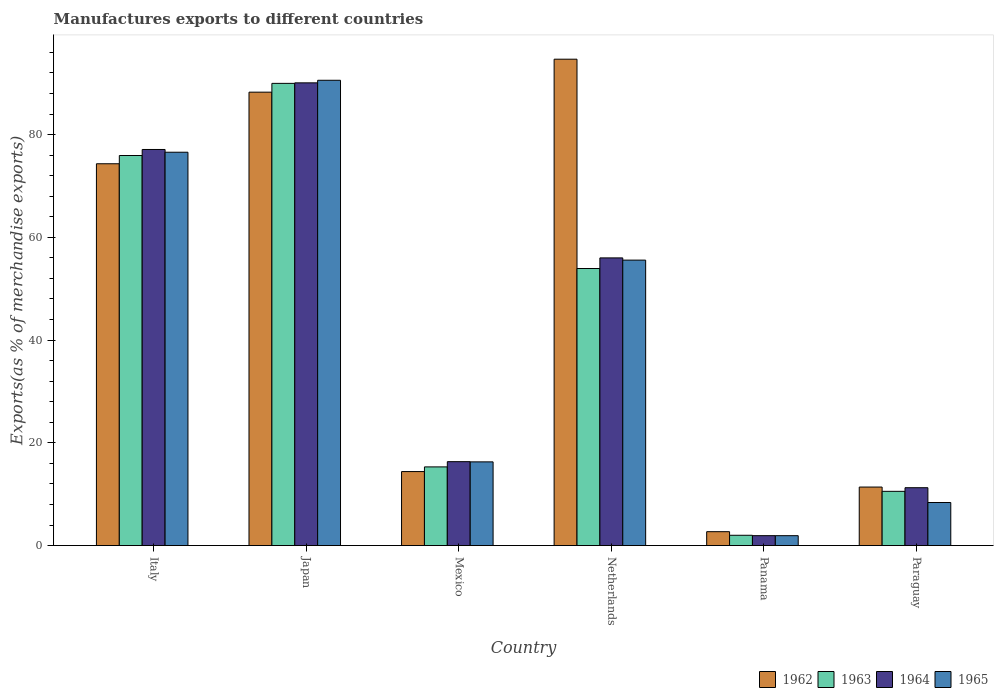How many different coloured bars are there?
Keep it short and to the point. 4. How many groups of bars are there?
Ensure brevity in your answer.  6. Are the number of bars per tick equal to the number of legend labels?
Keep it short and to the point. Yes. Are the number of bars on each tick of the X-axis equal?
Offer a very short reply. Yes. How many bars are there on the 2nd tick from the left?
Your response must be concise. 4. What is the label of the 2nd group of bars from the left?
Your answer should be compact. Japan. What is the percentage of exports to different countries in 1963 in Panama?
Offer a very short reply. 2. Across all countries, what is the maximum percentage of exports to different countries in 1964?
Offer a terse response. 90.07. Across all countries, what is the minimum percentage of exports to different countries in 1965?
Provide a succinct answer. 1.92. In which country was the percentage of exports to different countries in 1964 minimum?
Ensure brevity in your answer.  Panama. What is the total percentage of exports to different countries in 1963 in the graph?
Offer a very short reply. 247.71. What is the difference between the percentage of exports to different countries in 1965 in Netherlands and that in Panama?
Offer a terse response. 53.64. What is the difference between the percentage of exports to different countries in 1963 in Japan and the percentage of exports to different countries in 1964 in Panama?
Give a very brief answer. 88.04. What is the average percentage of exports to different countries in 1965 per country?
Offer a terse response. 41.55. What is the difference between the percentage of exports to different countries of/in 1963 and percentage of exports to different countries of/in 1964 in Italy?
Provide a short and direct response. -1.17. What is the ratio of the percentage of exports to different countries in 1962 in Italy to that in Mexico?
Keep it short and to the point. 5.16. Is the difference between the percentage of exports to different countries in 1963 in Mexico and Paraguay greater than the difference between the percentage of exports to different countries in 1964 in Mexico and Paraguay?
Ensure brevity in your answer.  No. What is the difference between the highest and the second highest percentage of exports to different countries in 1963?
Make the answer very short. 14.04. What is the difference between the highest and the lowest percentage of exports to different countries in 1962?
Keep it short and to the point. 91.97. In how many countries, is the percentage of exports to different countries in 1965 greater than the average percentage of exports to different countries in 1965 taken over all countries?
Your answer should be compact. 3. Is the sum of the percentage of exports to different countries in 1964 in Mexico and Paraguay greater than the maximum percentage of exports to different countries in 1963 across all countries?
Provide a short and direct response. No. Is it the case that in every country, the sum of the percentage of exports to different countries in 1964 and percentage of exports to different countries in 1963 is greater than the sum of percentage of exports to different countries in 1965 and percentage of exports to different countries in 1962?
Give a very brief answer. No. What does the 3rd bar from the left in Panama represents?
Make the answer very short. 1964. What does the 4th bar from the right in Mexico represents?
Your response must be concise. 1962. Is it the case that in every country, the sum of the percentage of exports to different countries in 1964 and percentage of exports to different countries in 1963 is greater than the percentage of exports to different countries in 1962?
Keep it short and to the point. Yes. Does the graph contain any zero values?
Your response must be concise. No. Where does the legend appear in the graph?
Provide a succinct answer. Bottom right. What is the title of the graph?
Offer a very short reply. Manufactures exports to different countries. What is the label or title of the X-axis?
Ensure brevity in your answer.  Country. What is the label or title of the Y-axis?
Your answer should be compact. Exports(as % of merchandise exports). What is the Exports(as % of merchandise exports) in 1962 in Italy?
Your response must be concise. 74.32. What is the Exports(as % of merchandise exports) of 1963 in Italy?
Provide a short and direct response. 75.93. What is the Exports(as % of merchandise exports) in 1964 in Italy?
Give a very brief answer. 77.1. What is the Exports(as % of merchandise exports) in 1965 in Italy?
Provide a short and direct response. 76.57. What is the Exports(as % of merchandise exports) of 1962 in Japan?
Your answer should be compact. 88.26. What is the Exports(as % of merchandise exports) of 1963 in Japan?
Keep it short and to the point. 89.97. What is the Exports(as % of merchandise exports) of 1964 in Japan?
Provide a short and direct response. 90.07. What is the Exports(as % of merchandise exports) of 1965 in Japan?
Give a very brief answer. 90.57. What is the Exports(as % of merchandise exports) in 1962 in Mexico?
Your answer should be very brief. 14.4. What is the Exports(as % of merchandise exports) of 1963 in Mexico?
Make the answer very short. 15.31. What is the Exports(as % of merchandise exports) in 1964 in Mexico?
Your answer should be very brief. 16.33. What is the Exports(as % of merchandise exports) of 1965 in Mexico?
Ensure brevity in your answer.  16.29. What is the Exports(as % of merchandise exports) in 1962 in Netherlands?
Offer a very short reply. 94.68. What is the Exports(as % of merchandise exports) in 1963 in Netherlands?
Keep it short and to the point. 53.93. What is the Exports(as % of merchandise exports) of 1964 in Netherlands?
Your response must be concise. 56. What is the Exports(as % of merchandise exports) of 1965 in Netherlands?
Your response must be concise. 55.57. What is the Exports(as % of merchandise exports) in 1962 in Panama?
Provide a short and direct response. 2.7. What is the Exports(as % of merchandise exports) of 1963 in Panama?
Your response must be concise. 2. What is the Exports(as % of merchandise exports) in 1964 in Panama?
Make the answer very short. 1.93. What is the Exports(as % of merchandise exports) in 1965 in Panama?
Offer a very short reply. 1.92. What is the Exports(as % of merchandise exports) in 1962 in Paraguay?
Offer a terse response. 11.39. What is the Exports(as % of merchandise exports) in 1963 in Paraguay?
Your response must be concise. 10.55. What is the Exports(as % of merchandise exports) of 1964 in Paraguay?
Offer a terse response. 11.26. What is the Exports(as % of merchandise exports) of 1965 in Paraguay?
Provide a short and direct response. 8.38. Across all countries, what is the maximum Exports(as % of merchandise exports) in 1962?
Make the answer very short. 94.68. Across all countries, what is the maximum Exports(as % of merchandise exports) of 1963?
Offer a very short reply. 89.97. Across all countries, what is the maximum Exports(as % of merchandise exports) of 1964?
Provide a short and direct response. 90.07. Across all countries, what is the maximum Exports(as % of merchandise exports) in 1965?
Your answer should be very brief. 90.57. Across all countries, what is the minimum Exports(as % of merchandise exports) in 1962?
Offer a terse response. 2.7. Across all countries, what is the minimum Exports(as % of merchandise exports) in 1963?
Ensure brevity in your answer.  2. Across all countries, what is the minimum Exports(as % of merchandise exports) in 1964?
Your answer should be compact. 1.93. Across all countries, what is the minimum Exports(as % of merchandise exports) in 1965?
Provide a short and direct response. 1.92. What is the total Exports(as % of merchandise exports) of 1962 in the graph?
Offer a terse response. 285.75. What is the total Exports(as % of merchandise exports) in 1963 in the graph?
Your answer should be compact. 247.71. What is the total Exports(as % of merchandise exports) of 1964 in the graph?
Ensure brevity in your answer.  252.69. What is the total Exports(as % of merchandise exports) in 1965 in the graph?
Offer a very short reply. 249.3. What is the difference between the Exports(as % of merchandise exports) of 1962 in Italy and that in Japan?
Your response must be concise. -13.94. What is the difference between the Exports(as % of merchandise exports) in 1963 in Italy and that in Japan?
Provide a short and direct response. -14.04. What is the difference between the Exports(as % of merchandise exports) in 1964 in Italy and that in Japan?
Your answer should be very brief. -12.97. What is the difference between the Exports(as % of merchandise exports) in 1965 in Italy and that in Japan?
Provide a short and direct response. -14.01. What is the difference between the Exports(as % of merchandise exports) in 1962 in Italy and that in Mexico?
Offer a very short reply. 59.92. What is the difference between the Exports(as % of merchandise exports) in 1963 in Italy and that in Mexico?
Offer a very short reply. 60.61. What is the difference between the Exports(as % of merchandise exports) in 1964 in Italy and that in Mexico?
Keep it short and to the point. 60.77. What is the difference between the Exports(as % of merchandise exports) of 1965 in Italy and that in Mexico?
Your response must be concise. 60.28. What is the difference between the Exports(as % of merchandise exports) of 1962 in Italy and that in Netherlands?
Make the answer very short. -20.36. What is the difference between the Exports(as % of merchandise exports) of 1963 in Italy and that in Netherlands?
Keep it short and to the point. 22. What is the difference between the Exports(as % of merchandise exports) in 1964 in Italy and that in Netherlands?
Make the answer very short. 21.11. What is the difference between the Exports(as % of merchandise exports) of 1965 in Italy and that in Netherlands?
Your response must be concise. 21. What is the difference between the Exports(as % of merchandise exports) of 1962 in Italy and that in Panama?
Make the answer very short. 71.62. What is the difference between the Exports(as % of merchandise exports) of 1963 in Italy and that in Panama?
Make the answer very short. 73.92. What is the difference between the Exports(as % of merchandise exports) in 1964 in Italy and that in Panama?
Your response must be concise. 75.18. What is the difference between the Exports(as % of merchandise exports) of 1965 in Italy and that in Panama?
Ensure brevity in your answer.  74.64. What is the difference between the Exports(as % of merchandise exports) of 1962 in Italy and that in Paraguay?
Provide a short and direct response. 62.93. What is the difference between the Exports(as % of merchandise exports) of 1963 in Italy and that in Paraguay?
Give a very brief answer. 65.37. What is the difference between the Exports(as % of merchandise exports) in 1964 in Italy and that in Paraguay?
Your answer should be very brief. 65.84. What is the difference between the Exports(as % of merchandise exports) in 1965 in Italy and that in Paraguay?
Your answer should be compact. 68.19. What is the difference between the Exports(as % of merchandise exports) of 1962 in Japan and that in Mexico?
Ensure brevity in your answer.  73.86. What is the difference between the Exports(as % of merchandise exports) in 1963 in Japan and that in Mexico?
Provide a short and direct response. 74.66. What is the difference between the Exports(as % of merchandise exports) in 1964 in Japan and that in Mexico?
Ensure brevity in your answer.  73.74. What is the difference between the Exports(as % of merchandise exports) in 1965 in Japan and that in Mexico?
Keep it short and to the point. 74.28. What is the difference between the Exports(as % of merchandise exports) of 1962 in Japan and that in Netherlands?
Your answer should be very brief. -6.42. What is the difference between the Exports(as % of merchandise exports) of 1963 in Japan and that in Netherlands?
Provide a short and direct response. 36.04. What is the difference between the Exports(as % of merchandise exports) in 1964 in Japan and that in Netherlands?
Provide a succinct answer. 34.07. What is the difference between the Exports(as % of merchandise exports) in 1965 in Japan and that in Netherlands?
Keep it short and to the point. 35.01. What is the difference between the Exports(as % of merchandise exports) in 1962 in Japan and that in Panama?
Give a very brief answer. 85.56. What is the difference between the Exports(as % of merchandise exports) in 1963 in Japan and that in Panama?
Your response must be concise. 87.97. What is the difference between the Exports(as % of merchandise exports) in 1964 in Japan and that in Panama?
Ensure brevity in your answer.  88.15. What is the difference between the Exports(as % of merchandise exports) of 1965 in Japan and that in Panama?
Your answer should be compact. 88.65. What is the difference between the Exports(as % of merchandise exports) in 1962 in Japan and that in Paraguay?
Your answer should be very brief. 76.87. What is the difference between the Exports(as % of merchandise exports) in 1963 in Japan and that in Paraguay?
Make the answer very short. 79.42. What is the difference between the Exports(as % of merchandise exports) of 1964 in Japan and that in Paraguay?
Ensure brevity in your answer.  78.81. What is the difference between the Exports(as % of merchandise exports) of 1965 in Japan and that in Paraguay?
Your answer should be very brief. 82.19. What is the difference between the Exports(as % of merchandise exports) of 1962 in Mexico and that in Netherlands?
Your answer should be very brief. -80.27. What is the difference between the Exports(as % of merchandise exports) of 1963 in Mexico and that in Netherlands?
Provide a short and direct response. -38.62. What is the difference between the Exports(as % of merchandise exports) of 1964 in Mexico and that in Netherlands?
Make the answer very short. -39.67. What is the difference between the Exports(as % of merchandise exports) in 1965 in Mexico and that in Netherlands?
Offer a very short reply. -39.28. What is the difference between the Exports(as % of merchandise exports) in 1962 in Mexico and that in Panama?
Give a very brief answer. 11.7. What is the difference between the Exports(as % of merchandise exports) of 1963 in Mexico and that in Panama?
Provide a short and direct response. 13.31. What is the difference between the Exports(as % of merchandise exports) of 1964 in Mexico and that in Panama?
Make the answer very short. 14.4. What is the difference between the Exports(as % of merchandise exports) of 1965 in Mexico and that in Panama?
Your response must be concise. 14.37. What is the difference between the Exports(as % of merchandise exports) in 1962 in Mexico and that in Paraguay?
Your response must be concise. 3.01. What is the difference between the Exports(as % of merchandise exports) in 1963 in Mexico and that in Paraguay?
Offer a very short reply. 4.76. What is the difference between the Exports(as % of merchandise exports) of 1964 in Mexico and that in Paraguay?
Offer a terse response. 5.07. What is the difference between the Exports(as % of merchandise exports) of 1965 in Mexico and that in Paraguay?
Provide a short and direct response. 7.91. What is the difference between the Exports(as % of merchandise exports) in 1962 in Netherlands and that in Panama?
Ensure brevity in your answer.  91.97. What is the difference between the Exports(as % of merchandise exports) of 1963 in Netherlands and that in Panama?
Give a very brief answer. 51.93. What is the difference between the Exports(as % of merchandise exports) of 1964 in Netherlands and that in Panama?
Give a very brief answer. 54.07. What is the difference between the Exports(as % of merchandise exports) in 1965 in Netherlands and that in Panama?
Offer a terse response. 53.64. What is the difference between the Exports(as % of merchandise exports) of 1962 in Netherlands and that in Paraguay?
Keep it short and to the point. 83.29. What is the difference between the Exports(as % of merchandise exports) of 1963 in Netherlands and that in Paraguay?
Your answer should be very brief. 43.38. What is the difference between the Exports(as % of merchandise exports) in 1964 in Netherlands and that in Paraguay?
Make the answer very short. 44.74. What is the difference between the Exports(as % of merchandise exports) of 1965 in Netherlands and that in Paraguay?
Offer a very short reply. 47.19. What is the difference between the Exports(as % of merchandise exports) of 1962 in Panama and that in Paraguay?
Keep it short and to the point. -8.69. What is the difference between the Exports(as % of merchandise exports) in 1963 in Panama and that in Paraguay?
Your answer should be very brief. -8.55. What is the difference between the Exports(as % of merchandise exports) in 1964 in Panama and that in Paraguay?
Ensure brevity in your answer.  -9.33. What is the difference between the Exports(as % of merchandise exports) of 1965 in Panama and that in Paraguay?
Provide a short and direct response. -6.46. What is the difference between the Exports(as % of merchandise exports) in 1962 in Italy and the Exports(as % of merchandise exports) in 1963 in Japan?
Offer a very short reply. -15.65. What is the difference between the Exports(as % of merchandise exports) of 1962 in Italy and the Exports(as % of merchandise exports) of 1964 in Japan?
Your response must be concise. -15.75. What is the difference between the Exports(as % of merchandise exports) of 1962 in Italy and the Exports(as % of merchandise exports) of 1965 in Japan?
Your answer should be compact. -16.25. What is the difference between the Exports(as % of merchandise exports) of 1963 in Italy and the Exports(as % of merchandise exports) of 1964 in Japan?
Keep it short and to the point. -14.14. What is the difference between the Exports(as % of merchandise exports) in 1963 in Italy and the Exports(as % of merchandise exports) in 1965 in Japan?
Offer a terse response. -14.64. What is the difference between the Exports(as % of merchandise exports) in 1964 in Italy and the Exports(as % of merchandise exports) in 1965 in Japan?
Your answer should be very brief. -13.47. What is the difference between the Exports(as % of merchandise exports) in 1962 in Italy and the Exports(as % of merchandise exports) in 1963 in Mexico?
Make the answer very short. 59.01. What is the difference between the Exports(as % of merchandise exports) in 1962 in Italy and the Exports(as % of merchandise exports) in 1964 in Mexico?
Your answer should be very brief. 57.99. What is the difference between the Exports(as % of merchandise exports) in 1962 in Italy and the Exports(as % of merchandise exports) in 1965 in Mexico?
Offer a terse response. 58.03. What is the difference between the Exports(as % of merchandise exports) of 1963 in Italy and the Exports(as % of merchandise exports) of 1964 in Mexico?
Offer a terse response. 59.6. What is the difference between the Exports(as % of merchandise exports) in 1963 in Italy and the Exports(as % of merchandise exports) in 1965 in Mexico?
Your answer should be very brief. 59.64. What is the difference between the Exports(as % of merchandise exports) in 1964 in Italy and the Exports(as % of merchandise exports) in 1965 in Mexico?
Your answer should be compact. 60.81. What is the difference between the Exports(as % of merchandise exports) in 1962 in Italy and the Exports(as % of merchandise exports) in 1963 in Netherlands?
Keep it short and to the point. 20.39. What is the difference between the Exports(as % of merchandise exports) in 1962 in Italy and the Exports(as % of merchandise exports) in 1964 in Netherlands?
Give a very brief answer. 18.32. What is the difference between the Exports(as % of merchandise exports) of 1962 in Italy and the Exports(as % of merchandise exports) of 1965 in Netherlands?
Your answer should be very brief. 18.76. What is the difference between the Exports(as % of merchandise exports) of 1963 in Italy and the Exports(as % of merchandise exports) of 1964 in Netherlands?
Provide a short and direct response. 19.93. What is the difference between the Exports(as % of merchandise exports) in 1963 in Italy and the Exports(as % of merchandise exports) in 1965 in Netherlands?
Ensure brevity in your answer.  20.36. What is the difference between the Exports(as % of merchandise exports) of 1964 in Italy and the Exports(as % of merchandise exports) of 1965 in Netherlands?
Keep it short and to the point. 21.54. What is the difference between the Exports(as % of merchandise exports) of 1962 in Italy and the Exports(as % of merchandise exports) of 1963 in Panama?
Provide a succinct answer. 72.32. What is the difference between the Exports(as % of merchandise exports) in 1962 in Italy and the Exports(as % of merchandise exports) in 1964 in Panama?
Offer a very short reply. 72.39. What is the difference between the Exports(as % of merchandise exports) in 1962 in Italy and the Exports(as % of merchandise exports) in 1965 in Panama?
Your response must be concise. 72.4. What is the difference between the Exports(as % of merchandise exports) in 1963 in Italy and the Exports(as % of merchandise exports) in 1964 in Panama?
Provide a succinct answer. 74. What is the difference between the Exports(as % of merchandise exports) in 1963 in Italy and the Exports(as % of merchandise exports) in 1965 in Panama?
Your response must be concise. 74.01. What is the difference between the Exports(as % of merchandise exports) in 1964 in Italy and the Exports(as % of merchandise exports) in 1965 in Panama?
Provide a succinct answer. 75.18. What is the difference between the Exports(as % of merchandise exports) of 1962 in Italy and the Exports(as % of merchandise exports) of 1963 in Paraguay?
Your answer should be very brief. 63.77. What is the difference between the Exports(as % of merchandise exports) in 1962 in Italy and the Exports(as % of merchandise exports) in 1964 in Paraguay?
Offer a terse response. 63.06. What is the difference between the Exports(as % of merchandise exports) of 1962 in Italy and the Exports(as % of merchandise exports) of 1965 in Paraguay?
Provide a succinct answer. 65.94. What is the difference between the Exports(as % of merchandise exports) of 1963 in Italy and the Exports(as % of merchandise exports) of 1964 in Paraguay?
Keep it short and to the point. 64.67. What is the difference between the Exports(as % of merchandise exports) of 1963 in Italy and the Exports(as % of merchandise exports) of 1965 in Paraguay?
Provide a succinct answer. 67.55. What is the difference between the Exports(as % of merchandise exports) in 1964 in Italy and the Exports(as % of merchandise exports) in 1965 in Paraguay?
Your answer should be compact. 68.72. What is the difference between the Exports(as % of merchandise exports) of 1962 in Japan and the Exports(as % of merchandise exports) of 1963 in Mexico?
Your response must be concise. 72.95. What is the difference between the Exports(as % of merchandise exports) of 1962 in Japan and the Exports(as % of merchandise exports) of 1964 in Mexico?
Offer a very short reply. 71.93. What is the difference between the Exports(as % of merchandise exports) in 1962 in Japan and the Exports(as % of merchandise exports) in 1965 in Mexico?
Offer a terse response. 71.97. What is the difference between the Exports(as % of merchandise exports) in 1963 in Japan and the Exports(as % of merchandise exports) in 1964 in Mexico?
Provide a succinct answer. 73.64. What is the difference between the Exports(as % of merchandise exports) in 1963 in Japan and the Exports(as % of merchandise exports) in 1965 in Mexico?
Your answer should be very brief. 73.68. What is the difference between the Exports(as % of merchandise exports) in 1964 in Japan and the Exports(as % of merchandise exports) in 1965 in Mexico?
Your answer should be compact. 73.78. What is the difference between the Exports(as % of merchandise exports) in 1962 in Japan and the Exports(as % of merchandise exports) in 1963 in Netherlands?
Provide a succinct answer. 34.33. What is the difference between the Exports(as % of merchandise exports) of 1962 in Japan and the Exports(as % of merchandise exports) of 1964 in Netherlands?
Make the answer very short. 32.26. What is the difference between the Exports(as % of merchandise exports) in 1962 in Japan and the Exports(as % of merchandise exports) in 1965 in Netherlands?
Your answer should be compact. 32.69. What is the difference between the Exports(as % of merchandise exports) in 1963 in Japan and the Exports(as % of merchandise exports) in 1964 in Netherlands?
Provide a short and direct response. 33.97. What is the difference between the Exports(as % of merchandise exports) of 1963 in Japan and the Exports(as % of merchandise exports) of 1965 in Netherlands?
Make the answer very short. 34.41. What is the difference between the Exports(as % of merchandise exports) of 1964 in Japan and the Exports(as % of merchandise exports) of 1965 in Netherlands?
Ensure brevity in your answer.  34.51. What is the difference between the Exports(as % of merchandise exports) of 1962 in Japan and the Exports(as % of merchandise exports) of 1963 in Panama?
Make the answer very short. 86.26. What is the difference between the Exports(as % of merchandise exports) of 1962 in Japan and the Exports(as % of merchandise exports) of 1964 in Panama?
Your response must be concise. 86.33. What is the difference between the Exports(as % of merchandise exports) of 1962 in Japan and the Exports(as % of merchandise exports) of 1965 in Panama?
Your answer should be very brief. 86.34. What is the difference between the Exports(as % of merchandise exports) of 1963 in Japan and the Exports(as % of merchandise exports) of 1964 in Panama?
Offer a terse response. 88.05. What is the difference between the Exports(as % of merchandise exports) of 1963 in Japan and the Exports(as % of merchandise exports) of 1965 in Panama?
Your answer should be compact. 88.05. What is the difference between the Exports(as % of merchandise exports) of 1964 in Japan and the Exports(as % of merchandise exports) of 1965 in Panama?
Your answer should be very brief. 88.15. What is the difference between the Exports(as % of merchandise exports) in 1962 in Japan and the Exports(as % of merchandise exports) in 1963 in Paraguay?
Offer a terse response. 77.71. What is the difference between the Exports(as % of merchandise exports) in 1962 in Japan and the Exports(as % of merchandise exports) in 1964 in Paraguay?
Make the answer very short. 77. What is the difference between the Exports(as % of merchandise exports) of 1962 in Japan and the Exports(as % of merchandise exports) of 1965 in Paraguay?
Offer a terse response. 79.88. What is the difference between the Exports(as % of merchandise exports) in 1963 in Japan and the Exports(as % of merchandise exports) in 1964 in Paraguay?
Offer a terse response. 78.71. What is the difference between the Exports(as % of merchandise exports) of 1963 in Japan and the Exports(as % of merchandise exports) of 1965 in Paraguay?
Offer a terse response. 81.59. What is the difference between the Exports(as % of merchandise exports) in 1964 in Japan and the Exports(as % of merchandise exports) in 1965 in Paraguay?
Provide a succinct answer. 81.69. What is the difference between the Exports(as % of merchandise exports) of 1962 in Mexico and the Exports(as % of merchandise exports) of 1963 in Netherlands?
Offer a very short reply. -39.53. What is the difference between the Exports(as % of merchandise exports) in 1962 in Mexico and the Exports(as % of merchandise exports) in 1964 in Netherlands?
Offer a terse response. -41.59. What is the difference between the Exports(as % of merchandise exports) of 1962 in Mexico and the Exports(as % of merchandise exports) of 1965 in Netherlands?
Your answer should be very brief. -41.16. What is the difference between the Exports(as % of merchandise exports) of 1963 in Mexico and the Exports(as % of merchandise exports) of 1964 in Netherlands?
Your response must be concise. -40.68. What is the difference between the Exports(as % of merchandise exports) of 1963 in Mexico and the Exports(as % of merchandise exports) of 1965 in Netherlands?
Provide a short and direct response. -40.25. What is the difference between the Exports(as % of merchandise exports) of 1964 in Mexico and the Exports(as % of merchandise exports) of 1965 in Netherlands?
Ensure brevity in your answer.  -39.24. What is the difference between the Exports(as % of merchandise exports) of 1962 in Mexico and the Exports(as % of merchandise exports) of 1963 in Panama?
Offer a very short reply. 12.4. What is the difference between the Exports(as % of merchandise exports) in 1962 in Mexico and the Exports(as % of merchandise exports) in 1964 in Panama?
Ensure brevity in your answer.  12.48. What is the difference between the Exports(as % of merchandise exports) in 1962 in Mexico and the Exports(as % of merchandise exports) in 1965 in Panama?
Give a very brief answer. 12.48. What is the difference between the Exports(as % of merchandise exports) in 1963 in Mexico and the Exports(as % of merchandise exports) in 1964 in Panama?
Ensure brevity in your answer.  13.39. What is the difference between the Exports(as % of merchandise exports) of 1963 in Mexico and the Exports(as % of merchandise exports) of 1965 in Panama?
Ensure brevity in your answer.  13.39. What is the difference between the Exports(as % of merchandise exports) of 1964 in Mexico and the Exports(as % of merchandise exports) of 1965 in Panama?
Keep it short and to the point. 14.41. What is the difference between the Exports(as % of merchandise exports) in 1962 in Mexico and the Exports(as % of merchandise exports) in 1963 in Paraguay?
Your answer should be very brief. 3.85. What is the difference between the Exports(as % of merchandise exports) in 1962 in Mexico and the Exports(as % of merchandise exports) in 1964 in Paraguay?
Offer a terse response. 3.14. What is the difference between the Exports(as % of merchandise exports) in 1962 in Mexico and the Exports(as % of merchandise exports) in 1965 in Paraguay?
Give a very brief answer. 6.02. What is the difference between the Exports(as % of merchandise exports) of 1963 in Mexico and the Exports(as % of merchandise exports) of 1964 in Paraguay?
Offer a very short reply. 4.05. What is the difference between the Exports(as % of merchandise exports) of 1963 in Mexico and the Exports(as % of merchandise exports) of 1965 in Paraguay?
Ensure brevity in your answer.  6.93. What is the difference between the Exports(as % of merchandise exports) in 1964 in Mexico and the Exports(as % of merchandise exports) in 1965 in Paraguay?
Keep it short and to the point. 7.95. What is the difference between the Exports(as % of merchandise exports) in 1962 in Netherlands and the Exports(as % of merchandise exports) in 1963 in Panama?
Your answer should be compact. 92.67. What is the difference between the Exports(as % of merchandise exports) in 1962 in Netherlands and the Exports(as % of merchandise exports) in 1964 in Panama?
Offer a very short reply. 92.75. What is the difference between the Exports(as % of merchandise exports) in 1962 in Netherlands and the Exports(as % of merchandise exports) in 1965 in Panama?
Give a very brief answer. 92.75. What is the difference between the Exports(as % of merchandise exports) in 1963 in Netherlands and the Exports(as % of merchandise exports) in 1964 in Panama?
Your answer should be compact. 52. What is the difference between the Exports(as % of merchandise exports) of 1963 in Netherlands and the Exports(as % of merchandise exports) of 1965 in Panama?
Offer a very short reply. 52.01. What is the difference between the Exports(as % of merchandise exports) in 1964 in Netherlands and the Exports(as % of merchandise exports) in 1965 in Panama?
Ensure brevity in your answer.  54.07. What is the difference between the Exports(as % of merchandise exports) of 1962 in Netherlands and the Exports(as % of merchandise exports) of 1963 in Paraguay?
Your answer should be very brief. 84.12. What is the difference between the Exports(as % of merchandise exports) of 1962 in Netherlands and the Exports(as % of merchandise exports) of 1964 in Paraguay?
Offer a terse response. 83.42. What is the difference between the Exports(as % of merchandise exports) in 1962 in Netherlands and the Exports(as % of merchandise exports) in 1965 in Paraguay?
Provide a short and direct response. 86.3. What is the difference between the Exports(as % of merchandise exports) in 1963 in Netherlands and the Exports(as % of merchandise exports) in 1964 in Paraguay?
Make the answer very short. 42.67. What is the difference between the Exports(as % of merchandise exports) in 1963 in Netherlands and the Exports(as % of merchandise exports) in 1965 in Paraguay?
Offer a very short reply. 45.55. What is the difference between the Exports(as % of merchandise exports) in 1964 in Netherlands and the Exports(as % of merchandise exports) in 1965 in Paraguay?
Keep it short and to the point. 47.62. What is the difference between the Exports(as % of merchandise exports) in 1962 in Panama and the Exports(as % of merchandise exports) in 1963 in Paraguay?
Ensure brevity in your answer.  -7.85. What is the difference between the Exports(as % of merchandise exports) of 1962 in Panama and the Exports(as % of merchandise exports) of 1964 in Paraguay?
Provide a short and direct response. -8.56. What is the difference between the Exports(as % of merchandise exports) of 1962 in Panama and the Exports(as % of merchandise exports) of 1965 in Paraguay?
Offer a terse response. -5.68. What is the difference between the Exports(as % of merchandise exports) of 1963 in Panama and the Exports(as % of merchandise exports) of 1964 in Paraguay?
Your answer should be compact. -9.26. What is the difference between the Exports(as % of merchandise exports) in 1963 in Panama and the Exports(as % of merchandise exports) in 1965 in Paraguay?
Make the answer very short. -6.38. What is the difference between the Exports(as % of merchandise exports) in 1964 in Panama and the Exports(as % of merchandise exports) in 1965 in Paraguay?
Provide a short and direct response. -6.45. What is the average Exports(as % of merchandise exports) in 1962 per country?
Ensure brevity in your answer.  47.63. What is the average Exports(as % of merchandise exports) in 1963 per country?
Provide a short and direct response. 41.28. What is the average Exports(as % of merchandise exports) of 1964 per country?
Provide a succinct answer. 42.12. What is the average Exports(as % of merchandise exports) in 1965 per country?
Your answer should be very brief. 41.55. What is the difference between the Exports(as % of merchandise exports) in 1962 and Exports(as % of merchandise exports) in 1963 in Italy?
Give a very brief answer. -1.61. What is the difference between the Exports(as % of merchandise exports) in 1962 and Exports(as % of merchandise exports) in 1964 in Italy?
Make the answer very short. -2.78. What is the difference between the Exports(as % of merchandise exports) in 1962 and Exports(as % of merchandise exports) in 1965 in Italy?
Your answer should be compact. -2.25. What is the difference between the Exports(as % of merchandise exports) of 1963 and Exports(as % of merchandise exports) of 1964 in Italy?
Offer a terse response. -1.17. What is the difference between the Exports(as % of merchandise exports) of 1963 and Exports(as % of merchandise exports) of 1965 in Italy?
Your response must be concise. -0.64. What is the difference between the Exports(as % of merchandise exports) of 1964 and Exports(as % of merchandise exports) of 1965 in Italy?
Provide a short and direct response. 0.54. What is the difference between the Exports(as % of merchandise exports) in 1962 and Exports(as % of merchandise exports) in 1963 in Japan?
Your response must be concise. -1.71. What is the difference between the Exports(as % of merchandise exports) in 1962 and Exports(as % of merchandise exports) in 1964 in Japan?
Keep it short and to the point. -1.81. What is the difference between the Exports(as % of merchandise exports) in 1962 and Exports(as % of merchandise exports) in 1965 in Japan?
Your answer should be compact. -2.31. What is the difference between the Exports(as % of merchandise exports) of 1963 and Exports(as % of merchandise exports) of 1964 in Japan?
Offer a very short reply. -0.1. What is the difference between the Exports(as % of merchandise exports) in 1963 and Exports(as % of merchandise exports) in 1965 in Japan?
Your answer should be very brief. -0.6. What is the difference between the Exports(as % of merchandise exports) of 1964 and Exports(as % of merchandise exports) of 1965 in Japan?
Your answer should be very brief. -0.5. What is the difference between the Exports(as % of merchandise exports) of 1962 and Exports(as % of merchandise exports) of 1963 in Mexico?
Ensure brevity in your answer.  -0.91. What is the difference between the Exports(as % of merchandise exports) in 1962 and Exports(as % of merchandise exports) in 1964 in Mexico?
Provide a short and direct response. -1.93. What is the difference between the Exports(as % of merchandise exports) in 1962 and Exports(as % of merchandise exports) in 1965 in Mexico?
Give a very brief answer. -1.89. What is the difference between the Exports(as % of merchandise exports) in 1963 and Exports(as % of merchandise exports) in 1964 in Mexico?
Your response must be concise. -1.02. What is the difference between the Exports(as % of merchandise exports) in 1963 and Exports(as % of merchandise exports) in 1965 in Mexico?
Your answer should be compact. -0.98. What is the difference between the Exports(as % of merchandise exports) of 1964 and Exports(as % of merchandise exports) of 1965 in Mexico?
Keep it short and to the point. 0.04. What is the difference between the Exports(as % of merchandise exports) in 1962 and Exports(as % of merchandise exports) in 1963 in Netherlands?
Provide a short and direct response. 40.75. What is the difference between the Exports(as % of merchandise exports) of 1962 and Exports(as % of merchandise exports) of 1964 in Netherlands?
Keep it short and to the point. 38.68. What is the difference between the Exports(as % of merchandise exports) of 1962 and Exports(as % of merchandise exports) of 1965 in Netherlands?
Make the answer very short. 39.11. What is the difference between the Exports(as % of merchandise exports) of 1963 and Exports(as % of merchandise exports) of 1964 in Netherlands?
Provide a succinct answer. -2.07. What is the difference between the Exports(as % of merchandise exports) of 1963 and Exports(as % of merchandise exports) of 1965 in Netherlands?
Your answer should be compact. -1.64. What is the difference between the Exports(as % of merchandise exports) in 1964 and Exports(as % of merchandise exports) in 1965 in Netherlands?
Offer a very short reply. 0.43. What is the difference between the Exports(as % of merchandise exports) in 1962 and Exports(as % of merchandise exports) in 1963 in Panama?
Your answer should be compact. 0.7. What is the difference between the Exports(as % of merchandise exports) in 1962 and Exports(as % of merchandise exports) in 1964 in Panama?
Keep it short and to the point. 0.78. What is the difference between the Exports(as % of merchandise exports) of 1962 and Exports(as % of merchandise exports) of 1965 in Panama?
Keep it short and to the point. 0.78. What is the difference between the Exports(as % of merchandise exports) of 1963 and Exports(as % of merchandise exports) of 1964 in Panama?
Ensure brevity in your answer.  0.08. What is the difference between the Exports(as % of merchandise exports) in 1963 and Exports(as % of merchandise exports) in 1965 in Panama?
Provide a succinct answer. 0.08. What is the difference between the Exports(as % of merchandise exports) of 1964 and Exports(as % of merchandise exports) of 1965 in Panama?
Your answer should be compact. 0. What is the difference between the Exports(as % of merchandise exports) in 1962 and Exports(as % of merchandise exports) in 1963 in Paraguay?
Your response must be concise. 0.83. What is the difference between the Exports(as % of merchandise exports) of 1962 and Exports(as % of merchandise exports) of 1964 in Paraguay?
Offer a very short reply. 0.13. What is the difference between the Exports(as % of merchandise exports) of 1962 and Exports(as % of merchandise exports) of 1965 in Paraguay?
Give a very brief answer. 3.01. What is the difference between the Exports(as % of merchandise exports) of 1963 and Exports(as % of merchandise exports) of 1964 in Paraguay?
Keep it short and to the point. -0.71. What is the difference between the Exports(as % of merchandise exports) of 1963 and Exports(as % of merchandise exports) of 1965 in Paraguay?
Your answer should be compact. 2.17. What is the difference between the Exports(as % of merchandise exports) of 1964 and Exports(as % of merchandise exports) of 1965 in Paraguay?
Offer a terse response. 2.88. What is the ratio of the Exports(as % of merchandise exports) of 1962 in Italy to that in Japan?
Your answer should be very brief. 0.84. What is the ratio of the Exports(as % of merchandise exports) of 1963 in Italy to that in Japan?
Offer a terse response. 0.84. What is the ratio of the Exports(as % of merchandise exports) of 1964 in Italy to that in Japan?
Give a very brief answer. 0.86. What is the ratio of the Exports(as % of merchandise exports) of 1965 in Italy to that in Japan?
Keep it short and to the point. 0.85. What is the ratio of the Exports(as % of merchandise exports) in 1962 in Italy to that in Mexico?
Keep it short and to the point. 5.16. What is the ratio of the Exports(as % of merchandise exports) of 1963 in Italy to that in Mexico?
Give a very brief answer. 4.96. What is the ratio of the Exports(as % of merchandise exports) of 1964 in Italy to that in Mexico?
Your answer should be compact. 4.72. What is the ratio of the Exports(as % of merchandise exports) of 1965 in Italy to that in Mexico?
Offer a very short reply. 4.7. What is the ratio of the Exports(as % of merchandise exports) of 1962 in Italy to that in Netherlands?
Make the answer very short. 0.79. What is the ratio of the Exports(as % of merchandise exports) of 1963 in Italy to that in Netherlands?
Your response must be concise. 1.41. What is the ratio of the Exports(as % of merchandise exports) in 1964 in Italy to that in Netherlands?
Keep it short and to the point. 1.38. What is the ratio of the Exports(as % of merchandise exports) of 1965 in Italy to that in Netherlands?
Your answer should be compact. 1.38. What is the ratio of the Exports(as % of merchandise exports) in 1962 in Italy to that in Panama?
Your answer should be very brief. 27.49. What is the ratio of the Exports(as % of merchandise exports) of 1963 in Italy to that in Panama?
Your response must be concise. 37.88. What is the ratio of the Exports(as % of merchandise exports) in 1964 in Italy to that in Panama?
Offer a terse response. 40.02. What is the ratio of the Exports(as % of merchandise exports) of 1965 in Italy to that in Panama?
Keep it short and to the point. 39.82. What is the ratio of the Exports(as % of merchandise exports) in 1962 in Italy to that in Paraguay?
Give a very brief answer. 6.53. What is the ratio of the Exports(as % of merchandise exports) of 1963 in Italy to that in Paraguay?
Your answer should be very brief. 7.19. What is the ratio of the Exports(as % of merchandise exports) of 1964 in Italy to that in Paraguay?
Your answer should be compact. 6.85. What is the ratio of the Exports(as % of merchandise exports) of 1965 in Italy to that in Paraguay?
Provide a short and direct response. 9.14. What is the ratio of the Exports(as % of merchandise exports) of 1962 in Japan to that in Mexico?
Your response must be concise. 6.13. What is the ratio of the Exports(as % of merchandise exports) in 1963 in Japan to that in Mexico?
Your response must be concise. 5.88. What is the ratio of the Exports(as % of merchandise exports) in 1964 in Japan to that in Mexico?
Your answer should be very brief. 5.52. What is the ratio of the Exports(as % of merchandise exports) in 1965 in Japan to that in Mexico?
Offer a very short reply. 5.56. What is the ratio of the Exports(as % of merchandise exports) in 1962 in Japan to that in Netherlands?
Provide a succinct answer. 0.93. What is the ratio of the Exports(as % of merchandise exports) of 1963 in Japan to that in Netherlands?
Your answer should be very brief. 1.67. What is the ratio of the Exports(as % of merchandise exports) of 1964 in Japan to that in Netherlands?
Make the answer very short. 1.61. What is the ratio of the Exports(as % of merchandise exports) in 1965 in Japan to that in Netherlands?
Your answer should be very brief. 1.63. What is the ratio of the Exports(as % of merchandise exports) of 1962 in Japan to that in Panama?
Offer a very short reply. 32.64. What is the ratio of the Exports(as % of merchandise exports) of 1963 in Japan to that in Panama?
Give a very brief answer. 44.89. What is the ratio of the Exports(as % of merchandise exports) in 1964 in Japan to that in Panama?
Provide a succinct answer. 46.75. What is the ratio of the Exports(as % of merchandise exports) in 1965 in Japan to that in Panama?
Keep it short and to the point. 47.1. What is the ratio of the Exports(as % of merchandise exports) of 1962 in Japan to that in Paraguay?
Your answer should be compact. 7.75. What is the ratio of the Exports(as % of merchandise exports) of 1963 in Japan to that in Paraguay?
Offer a very short reply. 8.52. What is the ratio of the Exports(as % of merchandise exports) in 1964 in Japan to that in Paraguay?
Ensure brevity in your answer.  8. What is the ratio of the Exports(as % of merchandise exports) of 1965 in Japan to that in Paraguay?
Your response must be concise. 10.81. What is the ratio of the Exports(as % of merchandise exports) in 1962 in Mexico to that in Netherlands?
Your answer should be compact. 0.15. What is the ratio of the Exports(as % of merchandise exports) in 1963 in Mexico to that in Netherlands?
Your answer should be very brief. 0.28. What is the ratio of the Exports(as % of merchandise exports) in 1964 in Mexico to that in Netherlands?
Keep it short and to the point. 0.29. What is the ratio of the Exports(as % of merchandise exports) in 1965 in Mexico to that in Netherlands?
Ensure brevity in your answer.  0.29. What is the ratio of the Exports(as % of merchandise exports) of 1962 in Mexico to that in Panama?
Your answer should be very brief. 5.33. What is the ratio of the Exports(as % of merchandise exports) of 1963 in Mexico to that in Panama?
Give a very brief answer. 7.64. What is the ratio of the Exports(as % of merchandise exports) in 1964 in Mexico to that in Panama?
Your answer should be very brief. 8.48. What is the ratio of the Exports(as % of merchandise exports) in 1965 in Mexico to that in Panama?
Give a very brief answer. 8.47. What is the ratio of the Exports(as % of merchandise exports) of 1962 in Mexico to that in Paraguay?
Your response must be concise. 1.26. What is the ratio of the Exports(as % of merchandise exports) of 1963 in Mexico to that in Paraguay?
Make the answer very short. 1.45. What is the ratio of the Exports(as % of merchandise exports) of 1964 in Mexico to that in Paraguay?
Your response must be concise. 1.45. What is the ratio of the Exports(as % of merchandise exports) in 1965 in Mexico to that in Paraguay?
Provide a succinct answer. 1.94. What is the ratio of the Exports(as % of merchandise exports) of 1962 in Netherlands to that in Panama?
Provide a succinct answer. 35.02. What is the ratio of the Exports(as % of merchandise exports) of 1963 in Netherlands to that in Panama?
Make the answer very short. 26.91. What is the ratio of the Exports(as % of merchandise exports) in 1964 in Netherlands to that in Panama?
Your answer should be very brief. 29.06. What is the ratio of the Exports(as % of merchandise exports) in 1965 in Netherlands to that in Panama?
Provide a succinct answer. 28.9. What is the ratio of the Exports(as % of merchandise exports) of 1962 in Netherlands to that in Paraguay?
Your response must be concise. 8.31. What is the ratio of the Exports(as % of merchandise exports) of 1963 in Netherlands to that in Paraguay?
Your answer should be very brief. 5.11. What is the ratio of the Exports(as % of merchandise exports) in 1964 in Netherlands to that in Paraguay?
Provide a short and direct response. 4.97. What is the ratio of the Exports(as % of merchandise exports) of 1965 in Netherlands to that in Paraguay?
Provide a short and direct response. 6.63. What is the ratio of the Exports(as % of merchandise exports) of 1962 in Panama to that in Paraguay?
Keep it short and to the point. 0.24. What is the ratio of the Exports(as % of merchandise exports) in 1963 in Panama to that in Paraguay?
Offer a terse response. 0.19. What is the ratio of the Exports(as % of merchandise exports) in 1964 in Panama to that in Paraguay?
Offer a very short reply. 0.17. What is the ratio of the Exports(as % of merchandise exports) of 1965 in Panama to that in Paraguay?
Your response must be concise. 0.23. What is the difference between the highest and the second highest Exports(as % of merchandise exports) in 1962?
Provide a succinct answer. 6.42. What is the difference between the highest and the second highest Exports(as % of merchandise exports) in 1963?
Offer a terse response. 14.04. What is the difference between the highest and the second highest Exports(as % of merchandise exports) in 1964?
Provide a succinct answer. 12.97. What is the difference between the highest and the second highest Exports(as % of merchandise exports) in 1965?
Keep it short and to the point. 14.01. What is the difference between the highest and the lowest Exports(as % of merchandise exports) of 1962?
Give a very brief answer. 91.97. What is the difference between the highest and the lowest Exports(as % of merchandise exports) in 1963?
Your answer should be compact. 87.97. What is the difference between the highest and the lowest Exports(as % of merchandise exports) in 1964?
Give a very brief answer. 88.15. What is the difference between the highest and the lowest Exports(as % of merchandise exports) of 1965?
Your response must be concise. 88.65. 